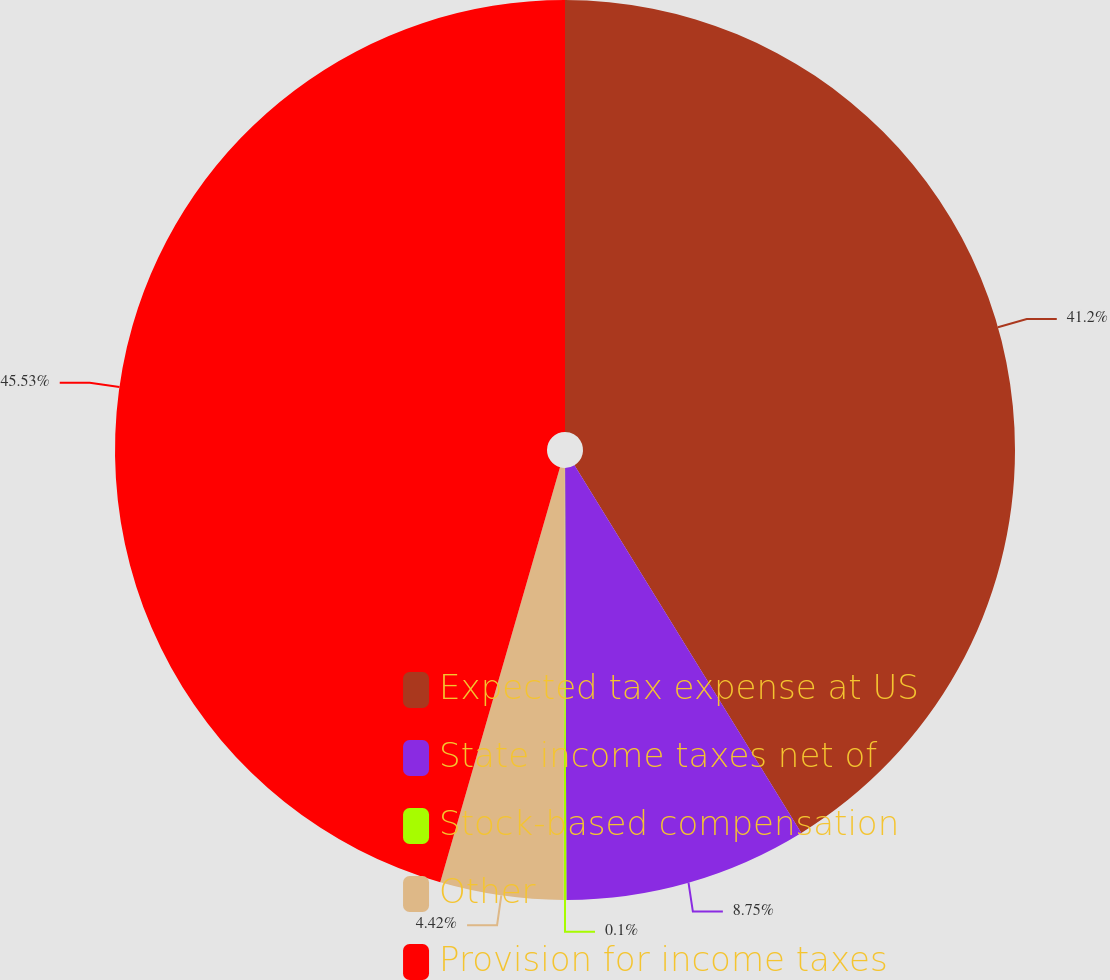<chart> <loc_0><loc_0><loc_500><loc_500><pie_chart><fcel>Expected tax expense at US<fcel>State income taxes net of<fcel>Stock-based compensation<fcel>Other<fcel>Provision for income taxes<nl><fcel>41.2%<fcel>8.75%<fcel>0.1%<fcel>4.42%<fcel>45.53%<nl></chart> 